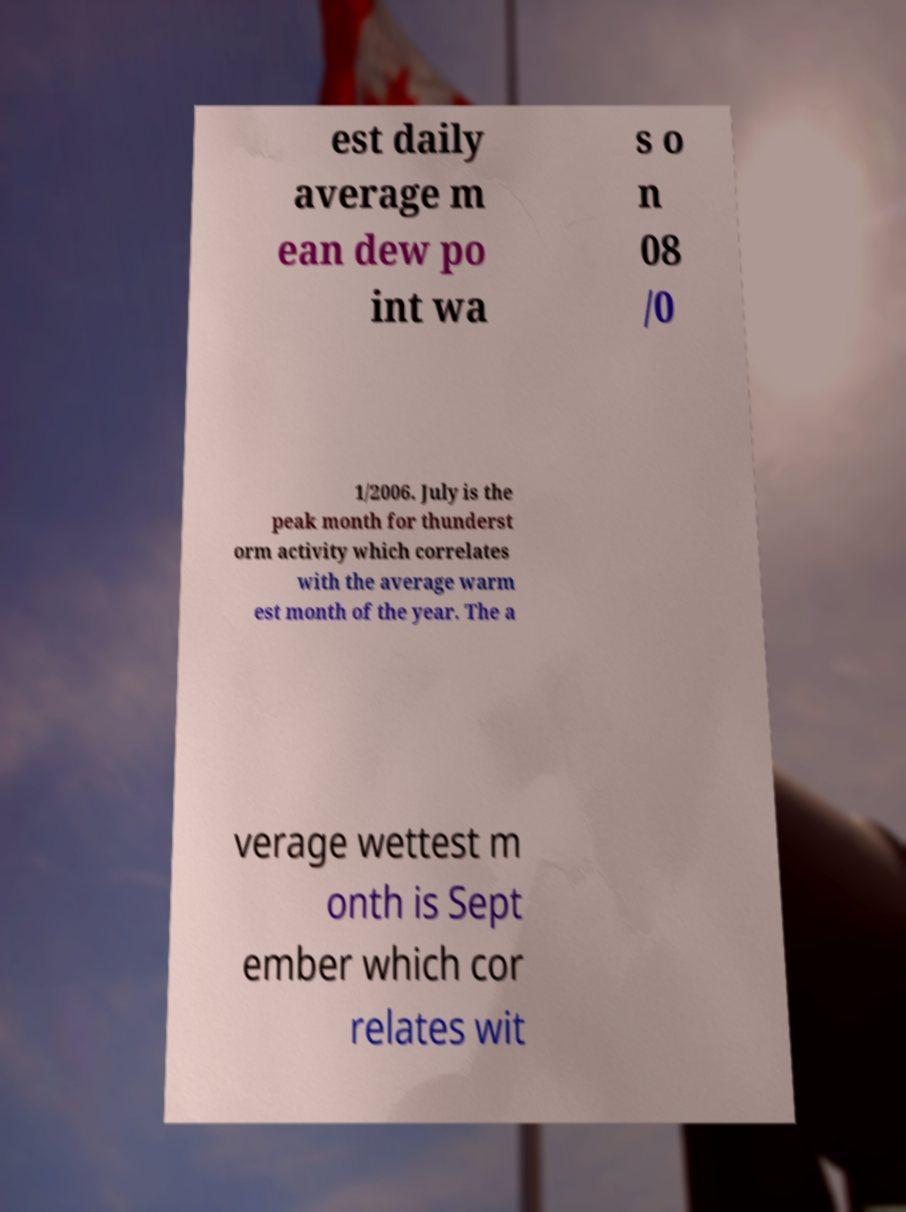Can you read and provide the text displayed in the image?This photo seems to have some interesting text. Can you extract and type it out for me? est daily average m ean dew po int wa s o n 08 /0 1/2006. July is the peak month for thunderst orm activity which correlates with the average warm est month of the year. The a verage wettest m onth is Sept ember which cor relates wit 